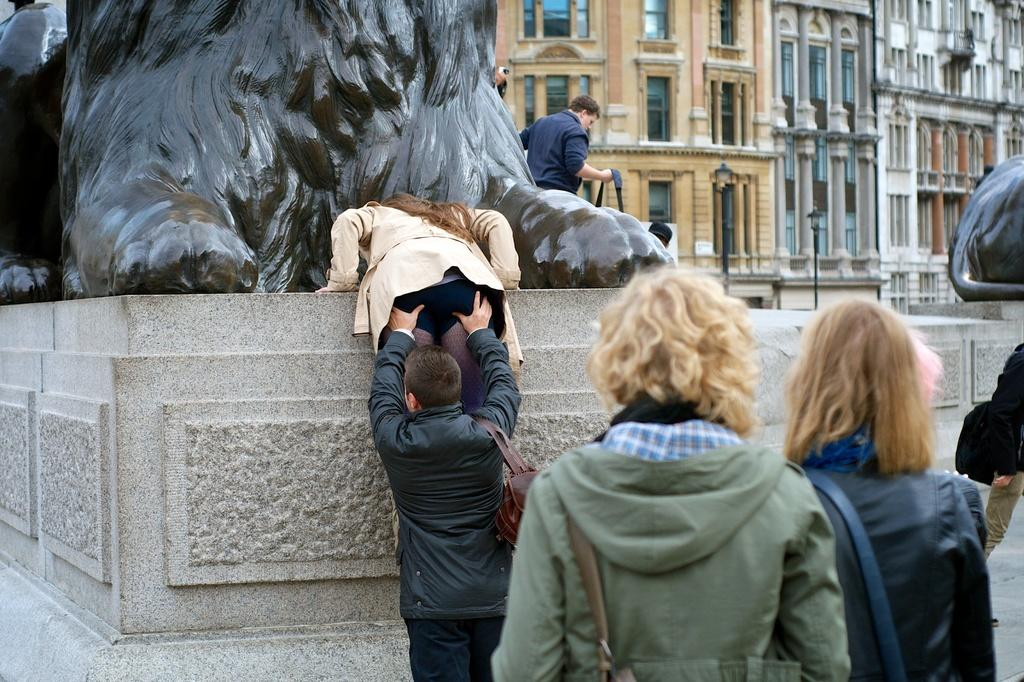How many people are in the image? There are people in the image. What are the people wearing? The people are wearing jackets. What can be seen in the background of the image? There are statues, buildings, and light poles in the background of the image. What feature do the buildings have? The buildings have windows. What action is being performed by a man in the image? A man is lifting a woman in the image. What is the opinion of the fifth person in the image? There is no mention of a fifth person in the image, so it is impossible to determine their opinion. 